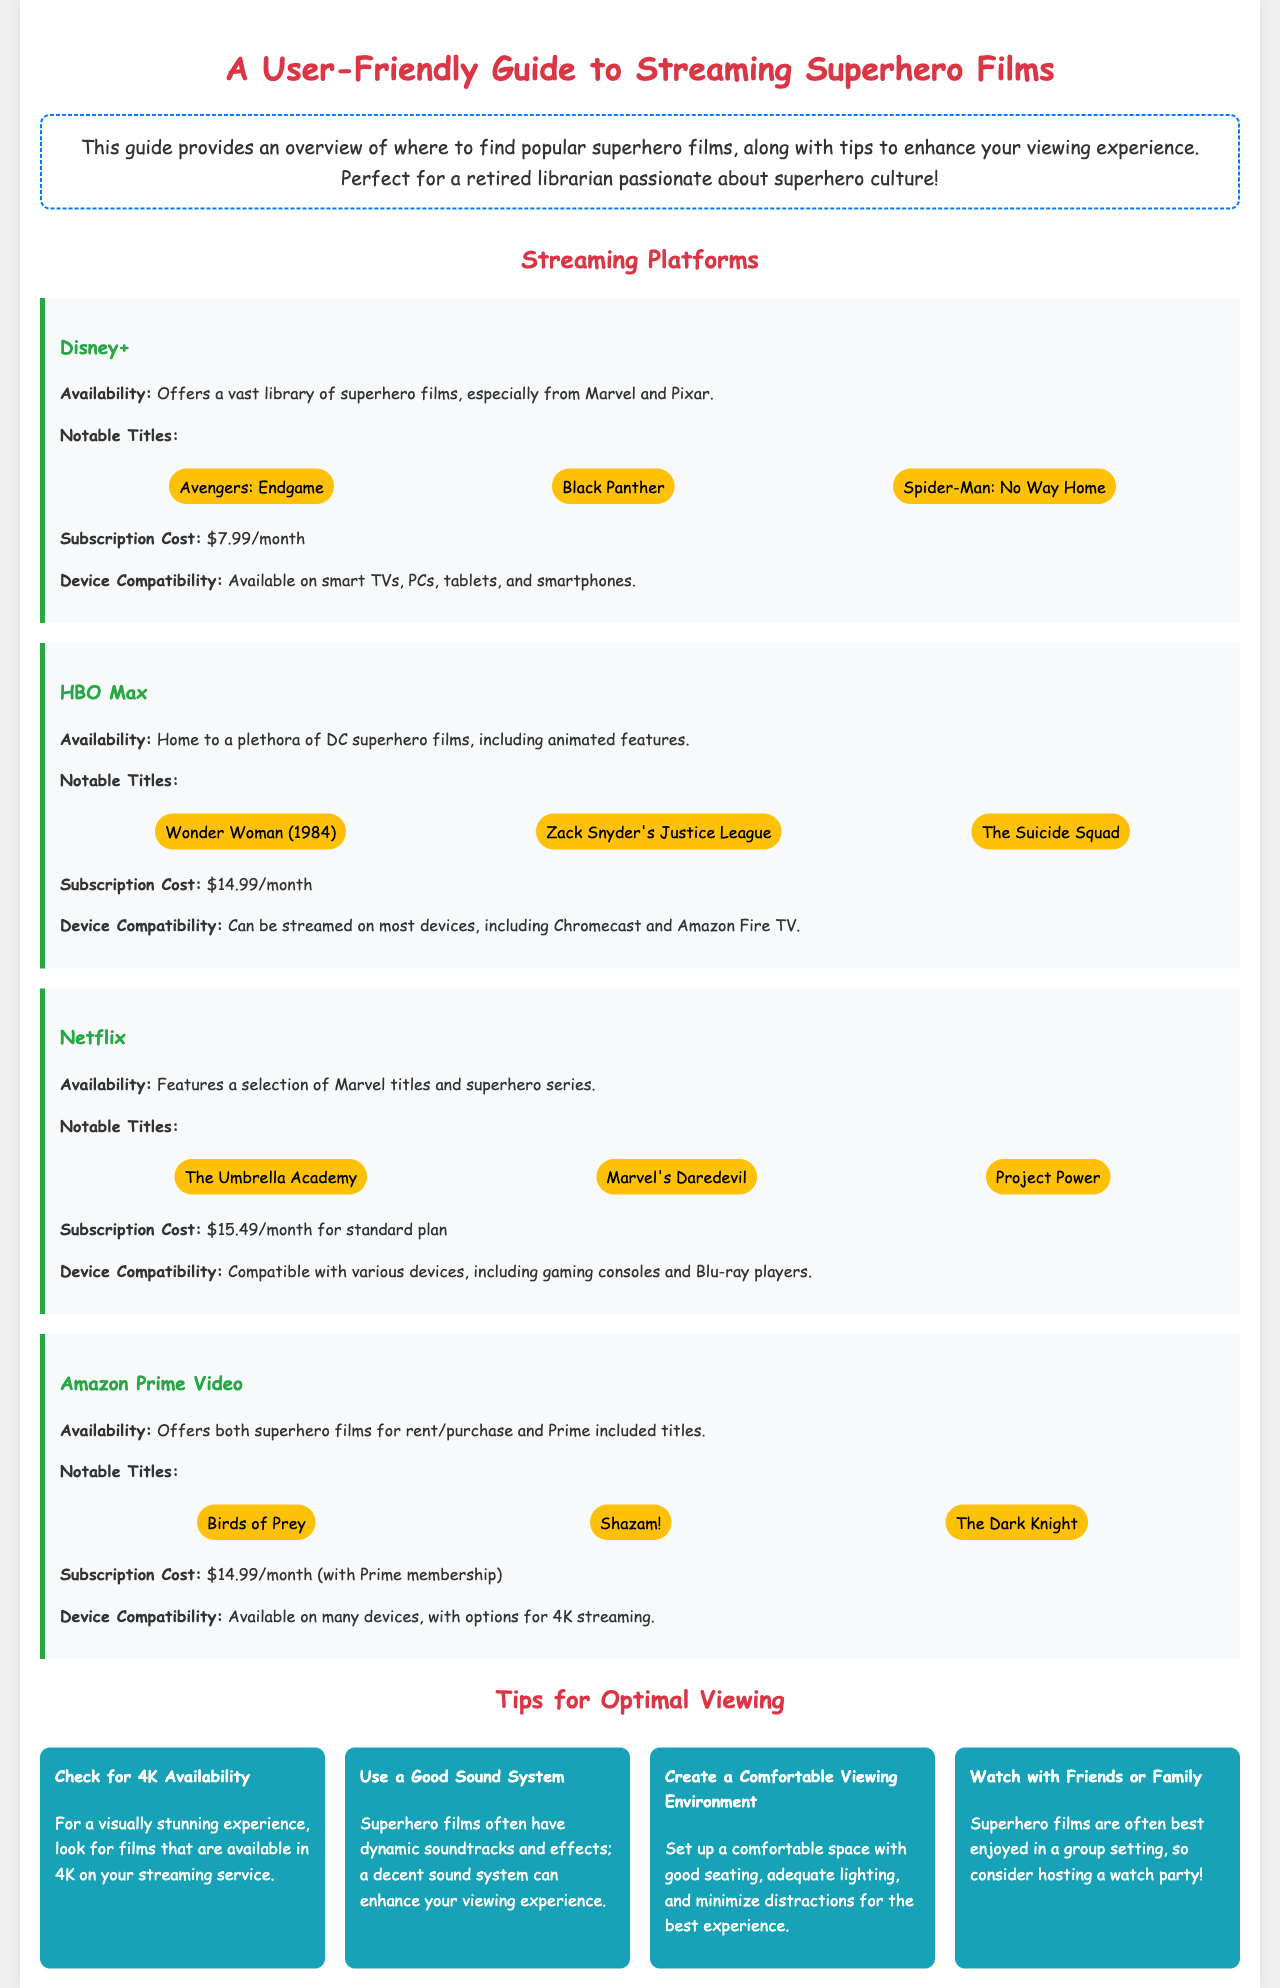What is the subscription cost for Disney+? The subscription cost for Disney+ is listed in the document as $7.99/month.
Answer: $7.99/month What notable titles are available on HBO Max? The notable titles available on HBO Max include Wonder Woman (1984), Zack Snyder's Justice League, and The Suicide Squad.
Answer: Wonder Woman (1984), Zack Snyder's Justice League, The Suicide Squad Which streaming platform has The Umbrella Academy? The Umbrella Academy is available on Netflix.
Answer: Netflix What is one of the tips for optimal viewing experience? The document lists several tips, one of which is to "Use a Good Sound System."
Answer: Use a Good Sound System How much is the subscription for Amazon Prime Video? The subscription cost for Amazon Prime Video is $14.99/month (with Prime membership).
Answer: $14.99/month (with Prime membership) What type of films does Disney+ mainly offer? Disney+ mainly offers superhero films, especially from Marvel and Pixar.
Answer: Superhero films, especially from Marvel and Pixar How many notable titles does Netflix feature in this guide? The guide mentions three notable titles for Netflix.
Answer: Three What is the device compatibility for HBO Max? The document states that HBO Max can be streamed on most devices, including Chromecast and Amazon Fire TV.
Answer: Most devices, including Chromecast and Amazon Fire TV What is the subscription cost for Netflix? The subscription cost for Netflix is $15.49/month for the standard plan.
Answer: $15.49/month 